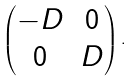<formula> <loc_0><loc_0><loc_500><loc_500>\begin{pmatrix} - D & 0 \\ 0 & D \end{pmatrix} .</formula> 